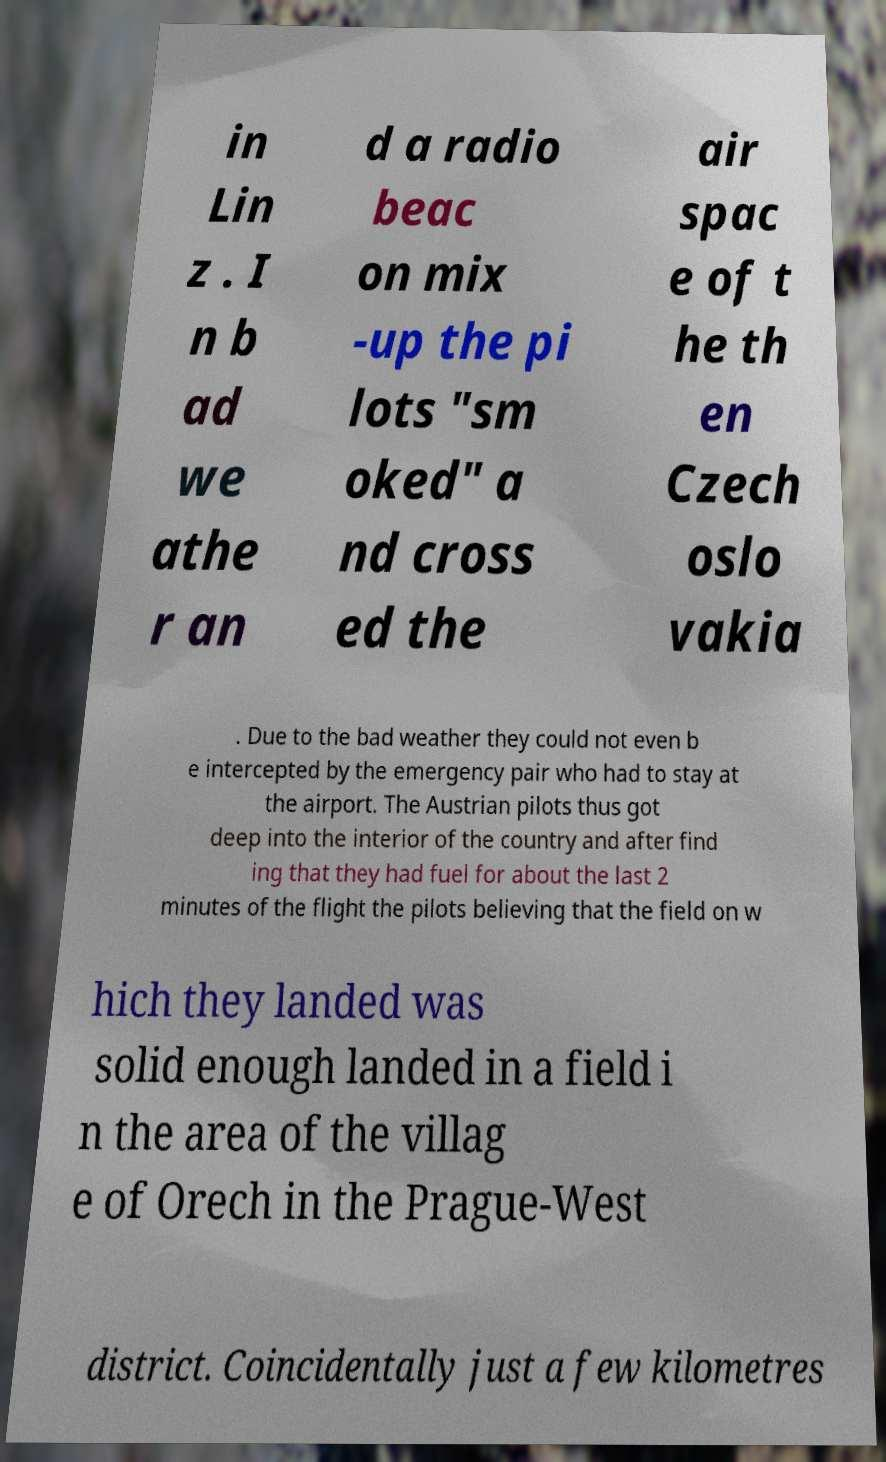There's text embedded in this image that I need extracted. Can you transcribe it verbatim? in Lin z . I n b ad we athe r an d a radio beac on mix -up the pi lots "sm oked" a nd cross ed the air spac e of t he th en Czech oslo vakia . Due to the bad weather they could not even b e intercepted by the emergency pair who had to stay at the airport. The Austrian pilots thus got deep into the interior of the country and after find ing that they had fuel for about the last 2 minutes of the flight the pilots believing that the field on w hich they landed was solid enough landed in a field i n the area of the villag e of Orech in the Prague-West district. Coincidentally just a few kilometres 